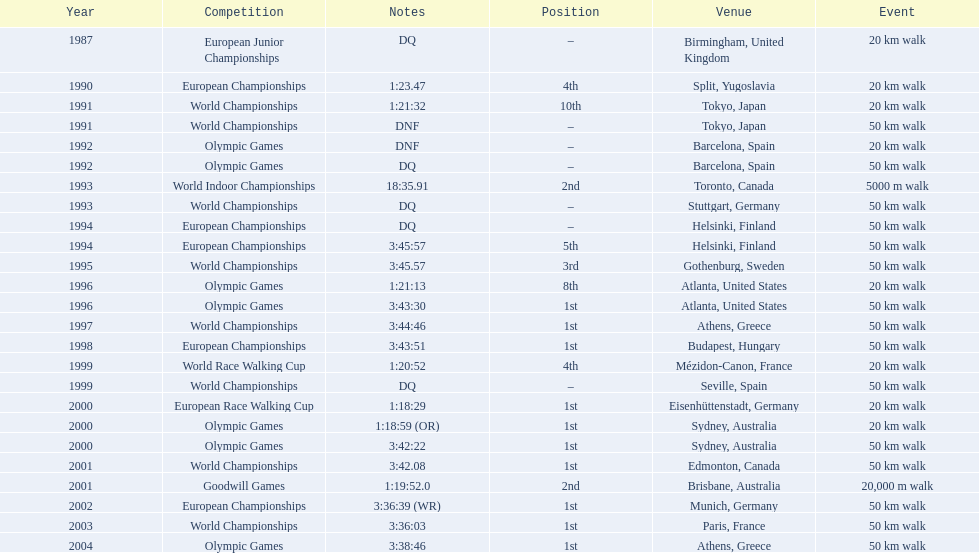How many events were at least 50 km? 17. 